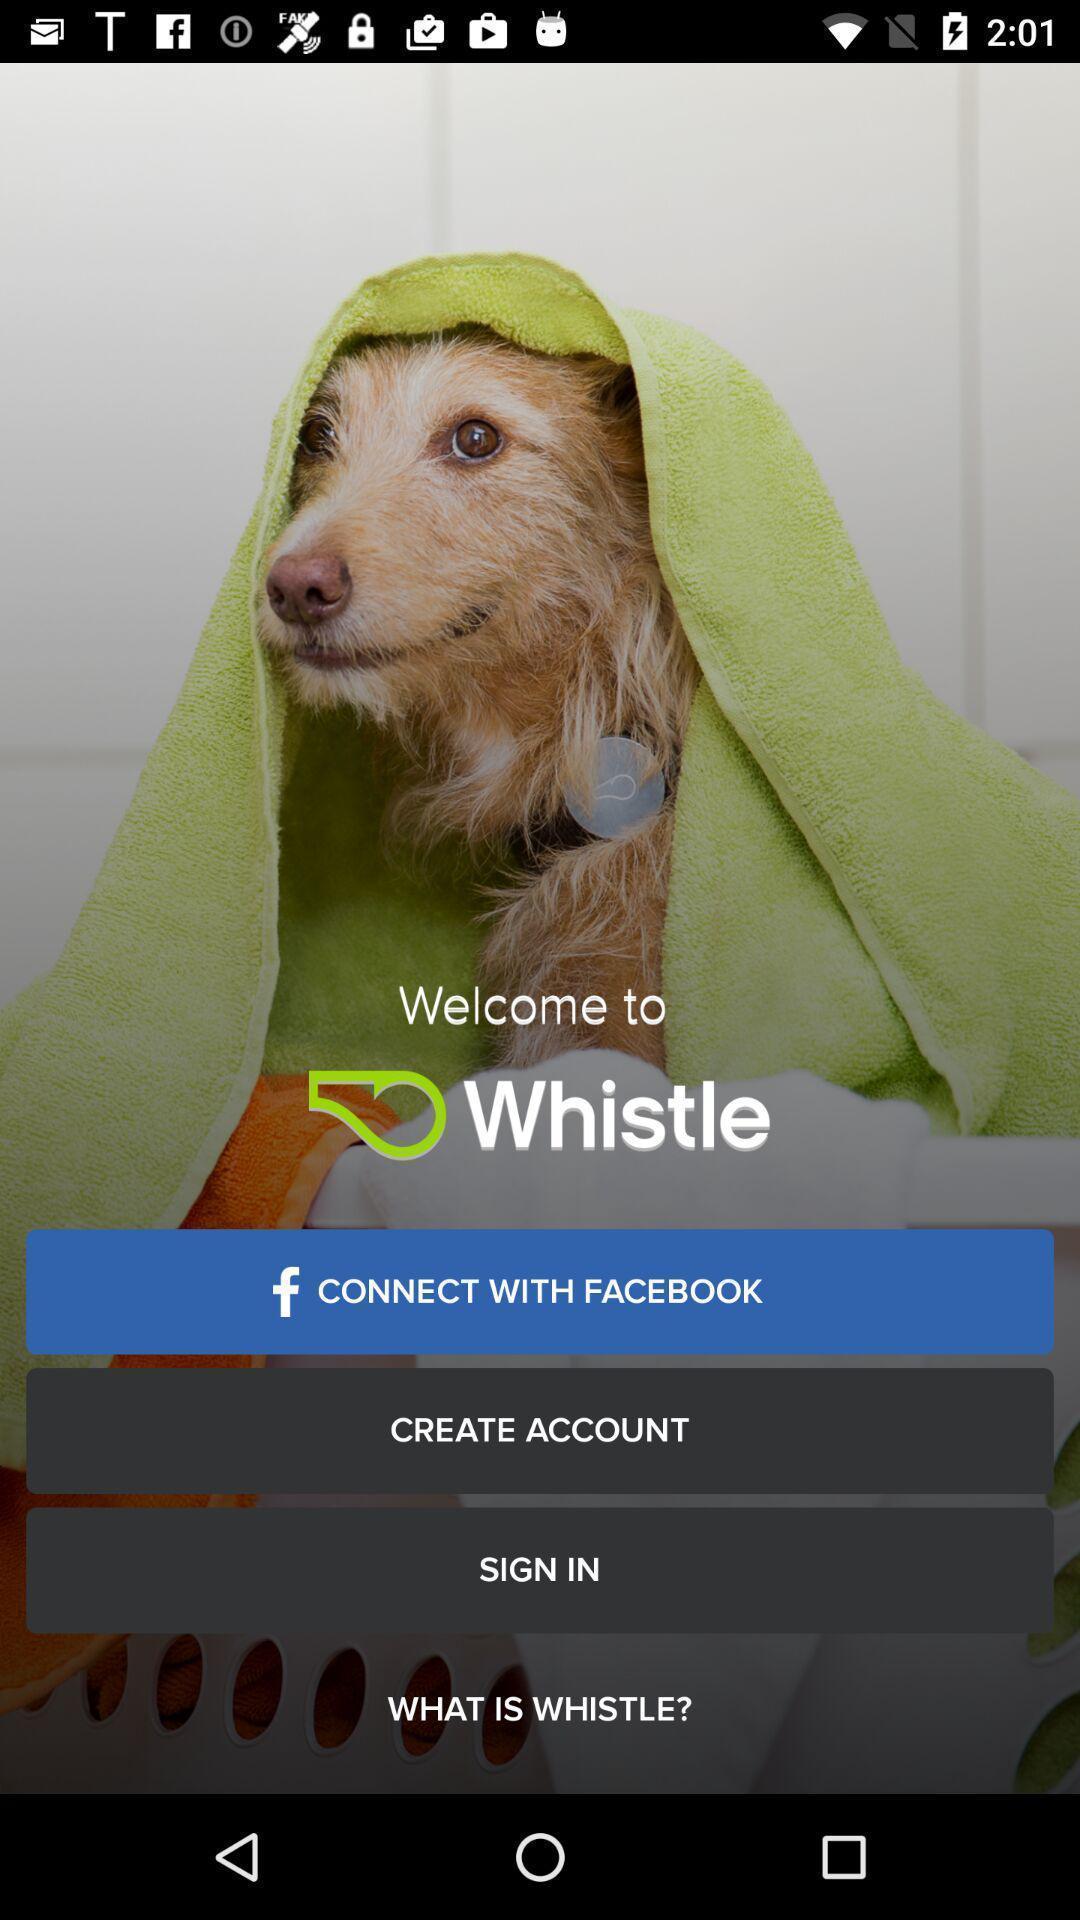Describe the key features of this screenshot. Welcome to the sign in page. 